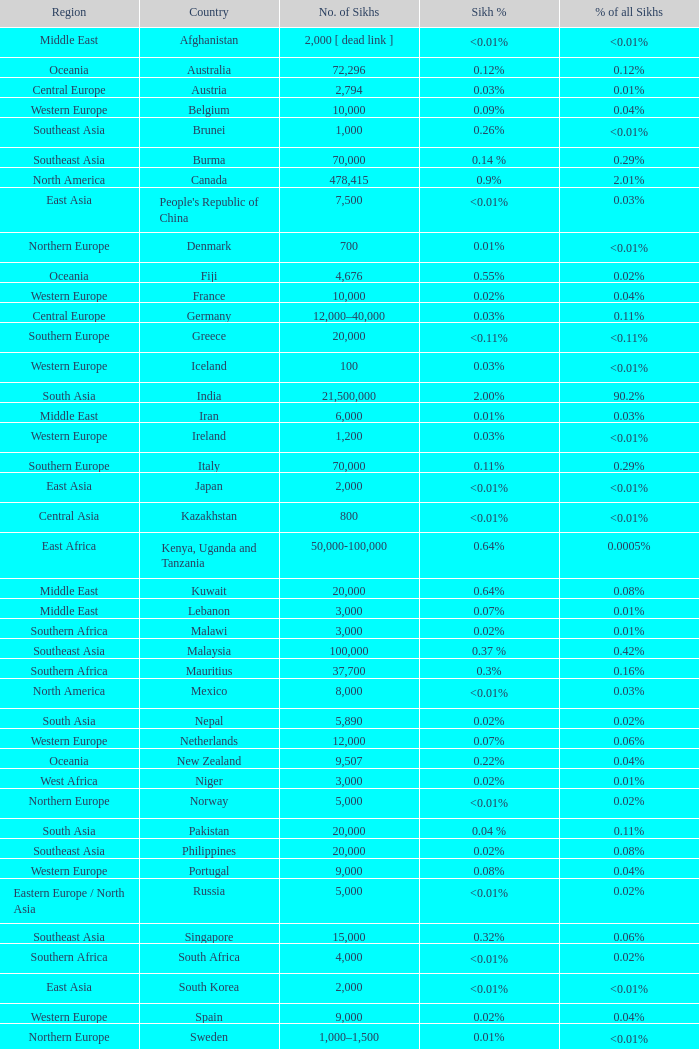What is the population of sikhs in japan? 2000.0. 